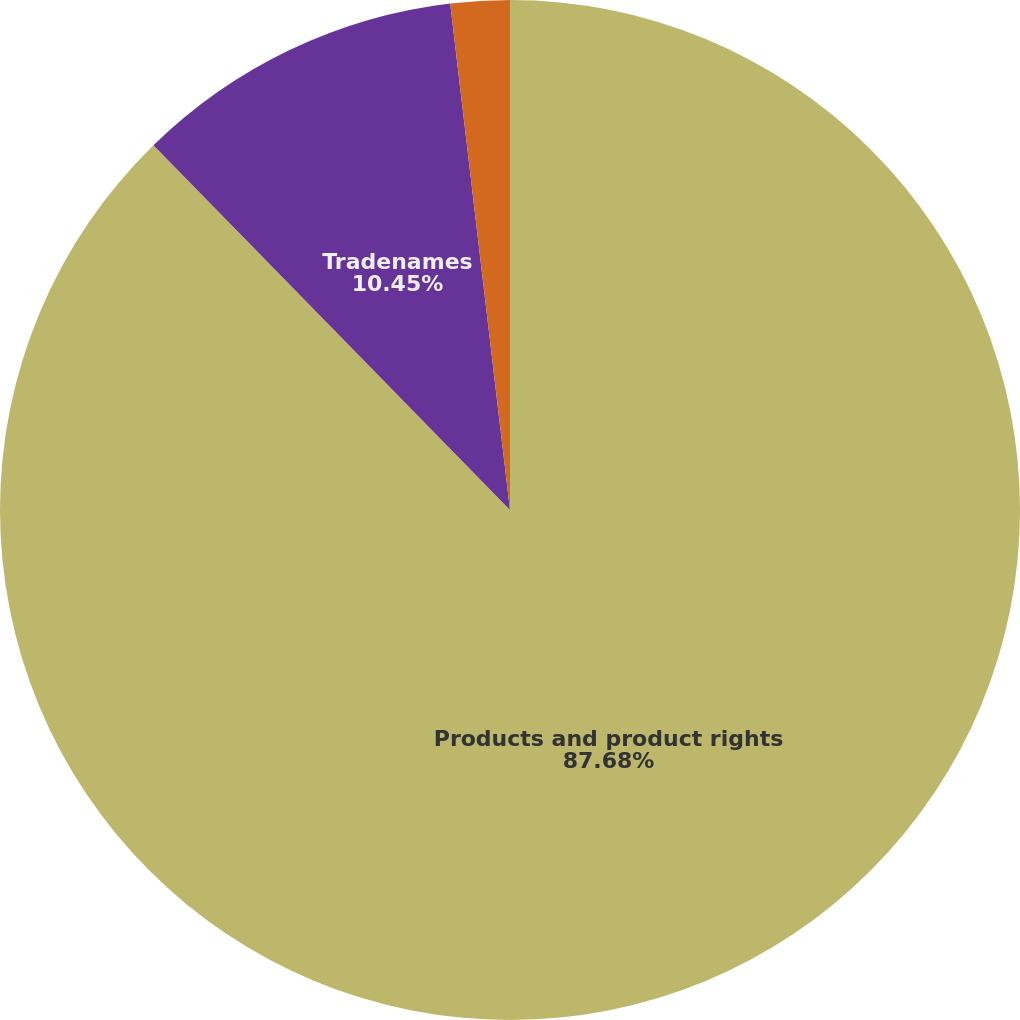Convert chart. <chart><loc_0><loc_0><loc_500><loc_500><pie_chart><fcel>Products and product rights<fcel>Tradenames<fcel>Other<nl><fcel>87.67%<fcel>10.45%<fcel>1.87%<nl></chart> 